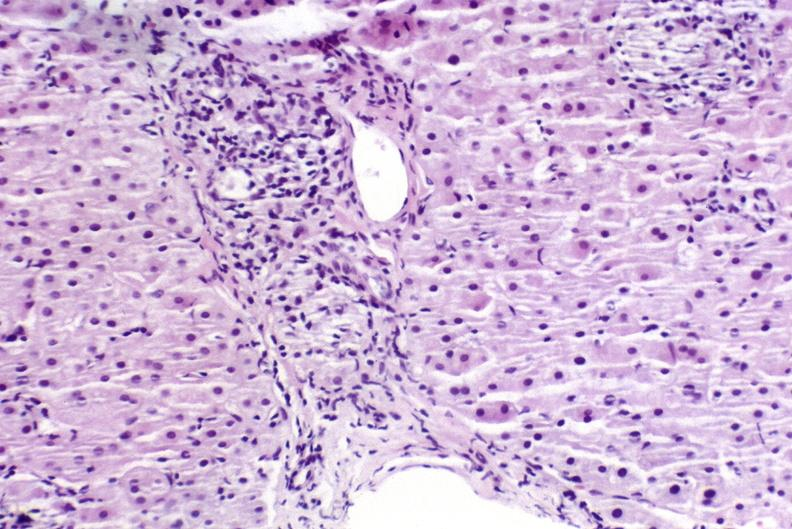what is present?
Answer the question using a single word or phrase. Liver 